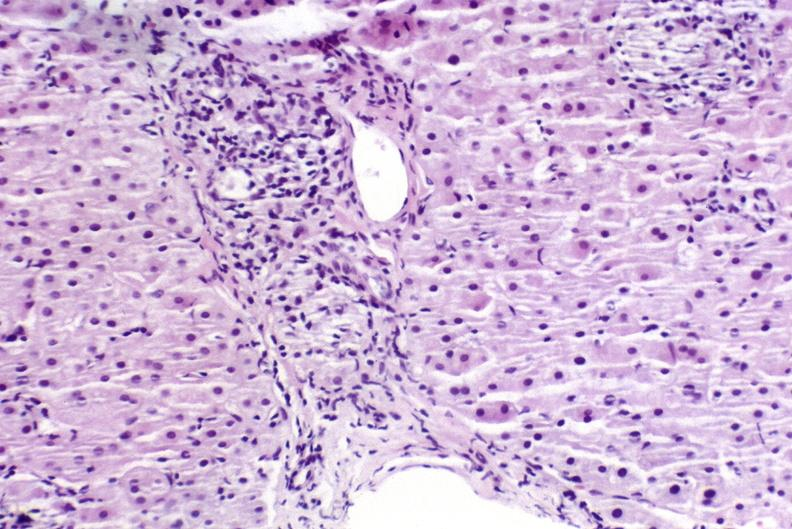what is present?
Answer the question using a single word or phrase. Liver 